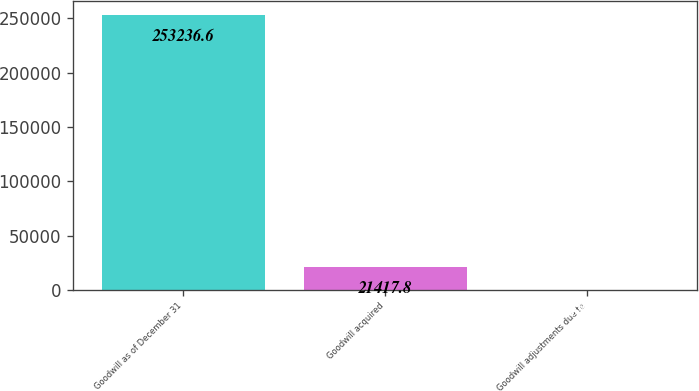Convert chart. <chart><loc_0><loc_0><loc_500><loc_500><bar_chart><fcel>Goodwill as of December 31<fcel>Goodwill acquired<fcel>Goodwill adjustments due to<nl><fcel>253237<fcel>21417.8<fcel>189<nl></chart> 